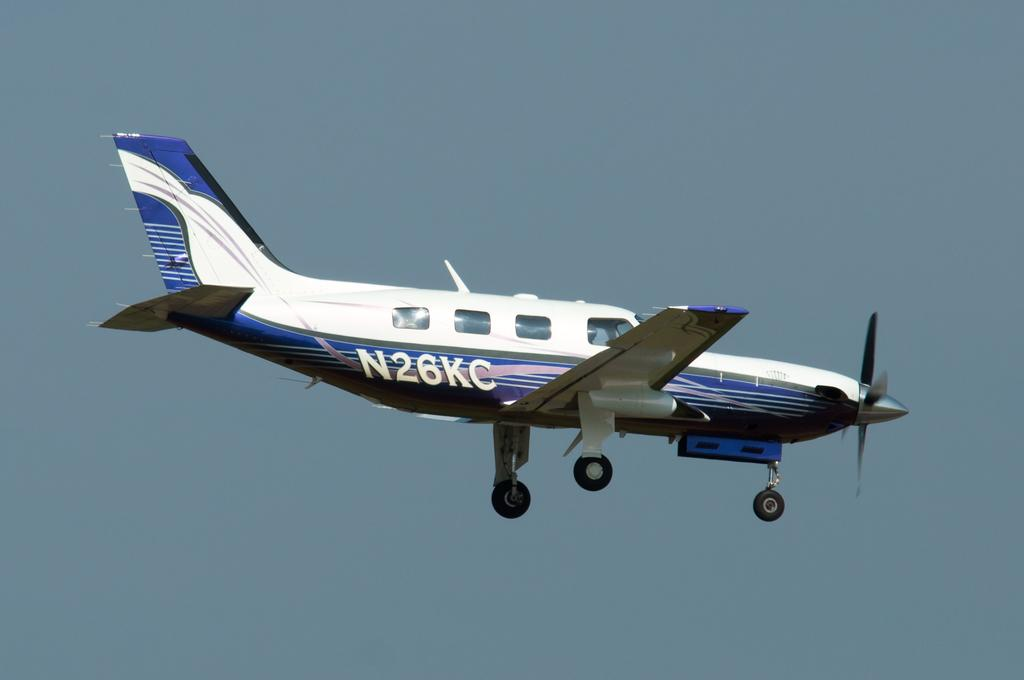Provide a one-sentence caption for the provided image. A blue and white plane with the tail number of N26KC is in flight. 